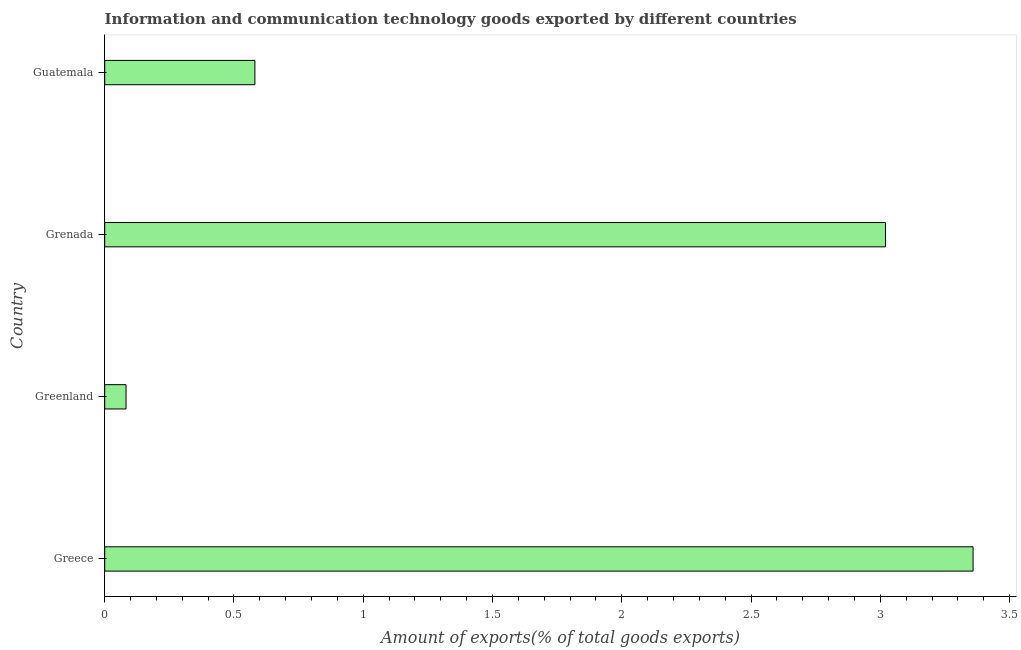Does the graph contain grids?
Offer a very short reply. No. What is the title of the graph?
Give a very brief answer. Information and communication technology goods exported by different countries. What is the label or title of the X-axis?
Your answer should be very brief. Amount of exports(% of total goods exports). What is the label or title of the Y-axis?
Give a very brief answer. Country. What is the amount of ict goods exports in Greenland?
Offer a very short reply. 0.08. Across all countries, what is the maximum amount of ict goods exports?
Make the answer very short. 3.36. Across all countries, what is the minimum amount of ict goods exports?
Offer a very short reply. 0.08. In which country was the amount of ict goods exports minimum?
Your answer should be very brief. Greenland. What is the sum of the amount of ict goods exports?
Your answer should be compact. 7.04. What is the difference between the amount of ict goods exports in Greece and Greenland?
Provide a succinct answer. 3.28. What is the average amount of ict goods exports per country?
Make the answer very short. 1.76. What is the median amount of ict goods exports?
Keep it short and to the point. 1.8. What is the ratio of the amount of ict goods exports in Greece to that in Guatemala?
Provide a succinct answer. 5.78. Is the amount of ict goods exports in Greenland less than that in Grenada?
Your response must be concise. Yes. What is the difference between the highest and the second highest amount of ict goods exports?
Make the answer very short. 0.34. What is the difference between the highest and the lowest amount of ict goods exports?
Provide a succinct answer. 3.28. How many bars are there?
Make the answer very short. 4. Are all the bars in the graph horizontal?
Make the answer very short. Yes. How many countries are there in the graph?
Give a very brief answer. 4. What is the Amount of exports(% of total goods exports) in Greece?
Offer a very short reply. 3.36. What is the Amount of exports(% of total goods exports) in Greenland?
Your answer should be very brief. 0.08. What is the Amount of exports(% of total goods exports) of Grenada?
Your answer should be very brief. 3.02. What is the Amount of exports(% of total goods exports) of Guatemala?
Provide a succinct answer. 0.58. What is the difference between the Amount of exports(% of total goods exports) in Greece and Greenland?
Offer a terse response. 3.28. What is the difference between the Amount of exports(% of total goods exports) in Greece and Grenada?
Offer a terse response. 0.34. What is the difference between the Amount of exports(% of total goods exports) in Greece and Guatemala?
Offer a terse response. 2.78. What is the difference between the Amount of exports(% of total goods exports) in Greenland and Grenada?
Your response must be concise. -2.94. What is the difference between the Amount of exports(% of total goods exports) in Greenland and Guatemala?
Provide a short and direct response. -0.5. What is the difference between the Amount of exports(% of total goods exports) in Grenada and Guatemala?
Keep it short and to the point. 2.44. What is the ratio of the Amount of exports(% of total goods exports) in Greece to that in Greenland?
Give a very brief answer. 40.72. What is the ratio of the Amount of exports(% of total goods exports) in Greece to that in Grenada?
Provide a short and direct response. 1.11. What is the ratio of the Amount of exports(% of total goods exports) in Greece to that in Guatemala?
Your answer should be compact. 5.78. What is the ratio of the Amount of exports(% of total goods exports) in Greenland to that in Grenada?
Give a very brief answer. 0.03. What is the ratio of the Amount of exports(% of total goods exports) in Greenland to that in Guatemala?
Offer a terse response. 0.14. What is the ratio of the Amount of exports(% of total goods exports) in Grenada to that in Guatemala?
Give a very brief answer. 5.2. 